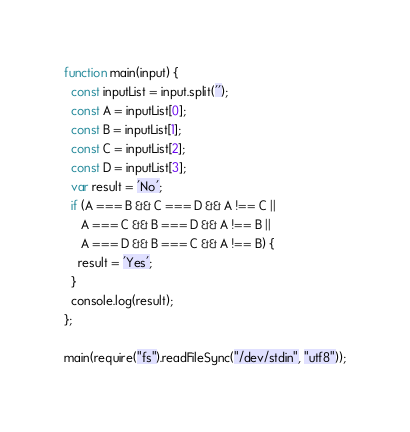<code> <loc_0><loc_0><loc_500><loc_500><_JavaScript_>function main(input) {
  const inputList = input.split('');
  const A = inputList[0];
  const B = inputList[1];
  const C = inputList[2];
  const D = inputList[3];
  var result = 'No';
  if (A === B && C === D && A !== C ||
     A === C && B === D && A !== B ||
     A === D && B === C && A !== B) {
    result = 'Yes';
  }
  console.log(result);
};

main(require("fs").readFileSync("/dev/stdin", "utf8"));
</code> 